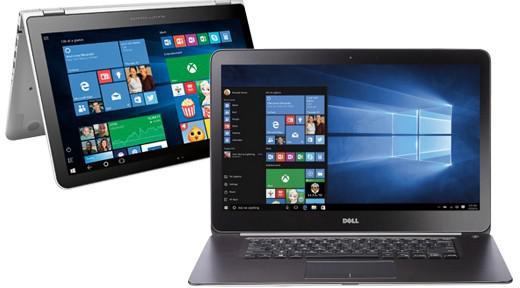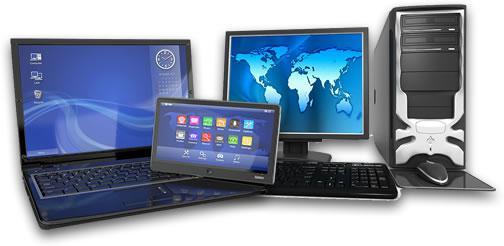The first image is the image on the left, the second image is the image on the right. Examine the images to the left and right. Is the description "The right image includes a greater number of devices than the left image." accurate? Answer yes or no. Yes. 